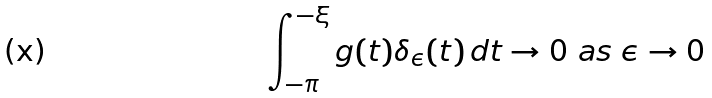Convert formula to latex. <formula><loc_0><loc_0><loc_500><loc_500>\int _ { - \pi } ^ { - \xi } g ( t ) \delta _ { \epsilon } ( t ) \, d t \rightarrow 0 \text { as } \epsilon \rightarrow 0</formula> 